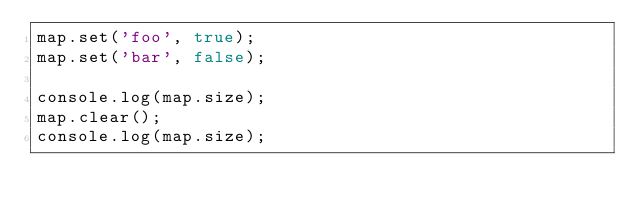Convert code to text. <code><loc_0><loc_0><loc_500><loc_500><_JavaScript_>map.set('foo', true);
map.set('bar', false);

console.log(map.size);
map.clear();
console.log(map.size);

</code> 